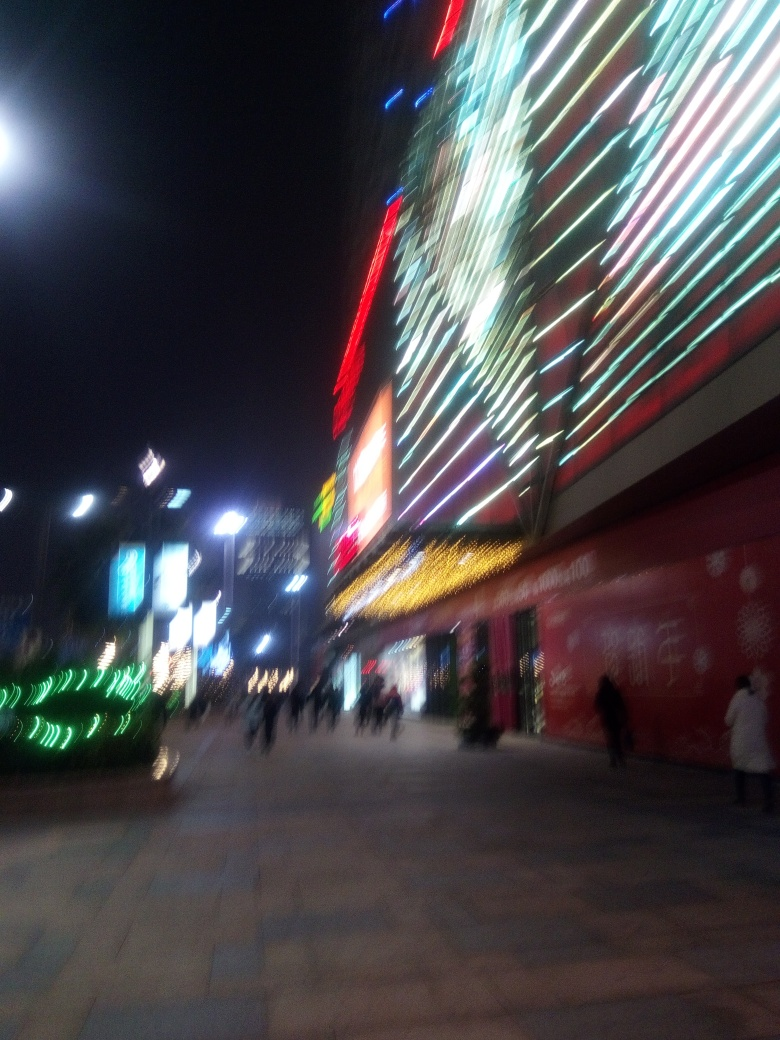Why is the portrayal of the subject unclear? The portrayal of the subject in this image is unclear primarily due to severe motion blur, which is a common issue when the camera or subject moves during the exposure. This results in a smeared or streaked appearance, as seen with the lights and people in this nighttime scene, reducing detail and sharpness. 